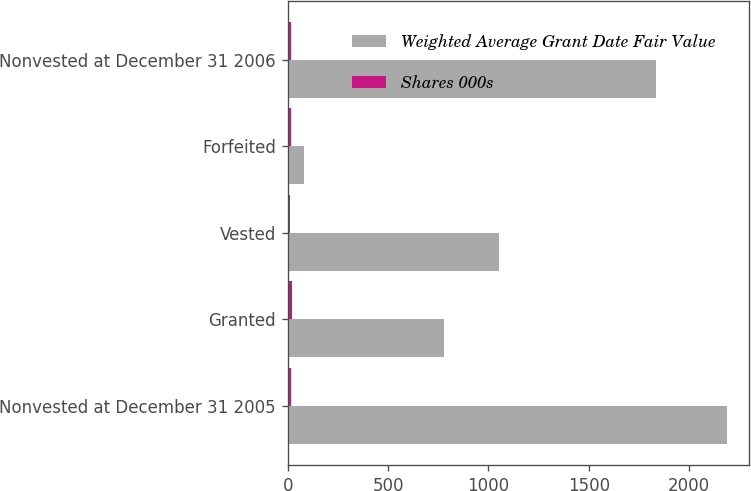<chart> <loc_0><loc_0><loc_500><loc_500><stacked_bar_chart><ecel><fcel>Nonvested at December 31 2005<fcel>Granted<fcel>Vested<fcel>Forfeited<fcel>Nonvested at December 31 2006<nl><fcel>Weighted Average Grant Date Fair Value<fcel>2187<fcel>781<fcel>1055<fcel>80<fcel>1833<nl><fcel>Shares 000s<fcel>14.61<fcel>20.95<fcel>11.94<fcel>18.51<fcel>18.68<nl></chart> 